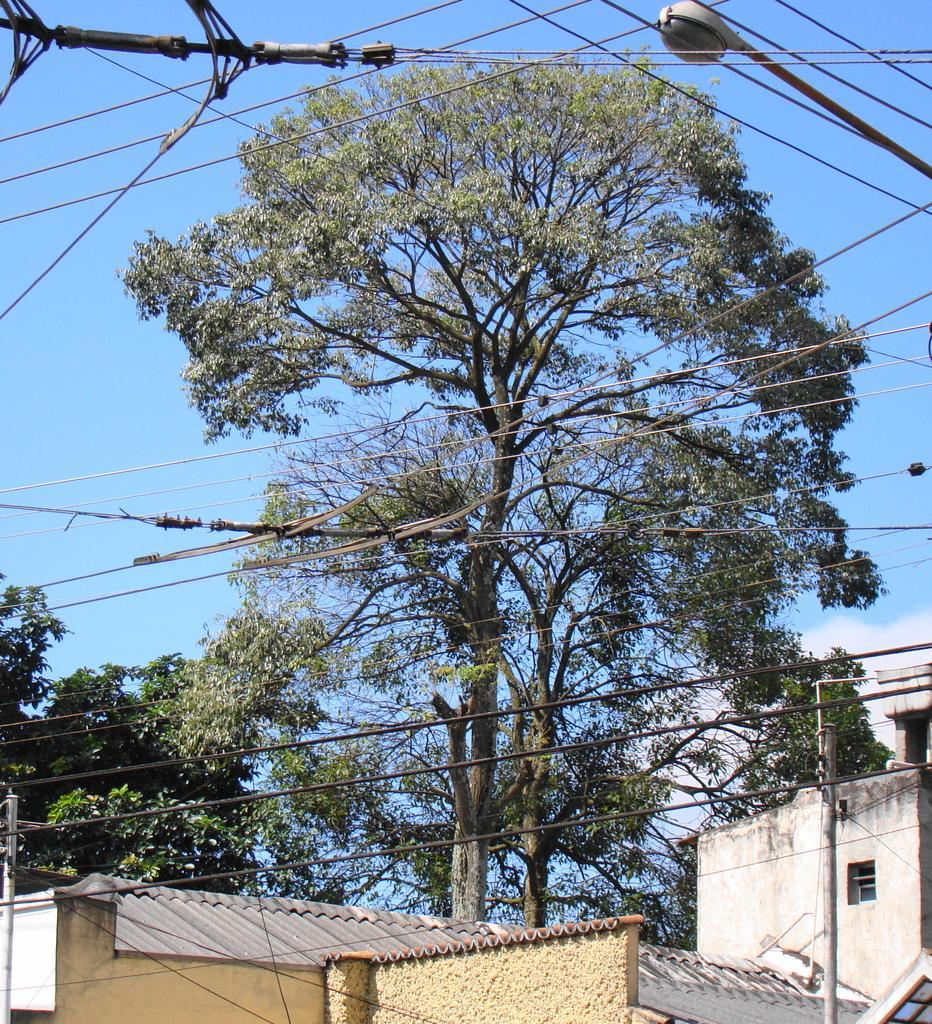Can you describe this image briefly? In this image I can see few buildings in cream and gray color. Background I can trees in green color, a light pole and sky is in blue color. 